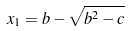<formula> <loc_0><loc_0><loc_500><loc_500>x _ { 1 } = b - \sqrt { b ^ { 2 } - c }</formula> 